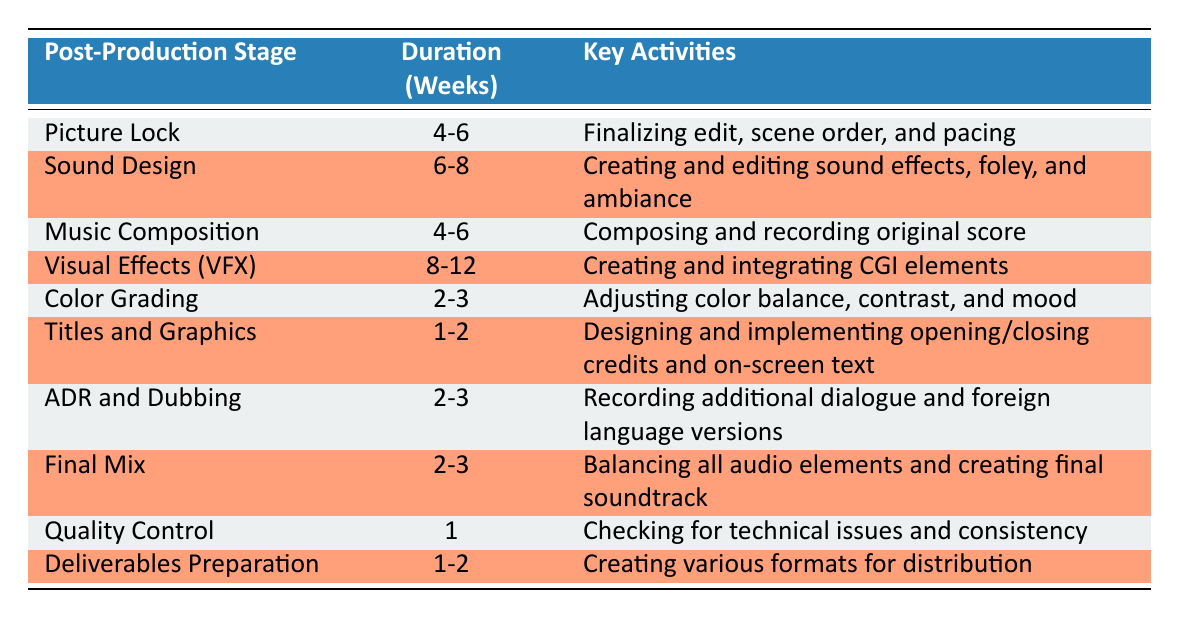What is the duration for the Picture Lock stage? The table lists the duration for the Picture Lock stage as 4-6 weeks.
Answer: 4-6 weeks How many weeks are allocated for Sound Design? The table indicates that Sound Design takes 6-8 weeks.
Answer: 6-8 weeks Is Color Grading shorter in duration than Titles and Graphics? Upon comparing the durations, Color Grading takes 2-3 weeks while Titles and Graphics takes 1-2 weeks. Since 2-3 weeks is greater than 1-2 weeks, this statement is false.
Answer: No What are the key activities during the Visual Effects (VFX) stage? According to the table, the key activities during the Visual Effects (VFX) stage are creating and integrating CGI elements.
Answer: Creating and integrating CGI elements What is the average duration for the ADR and Dubbing and Final Mix stages combined? The duration for ADR and Dubbing is 2-3 weeks and for Final Mix is also 2-3 weeks. To find the average, we will consider the midpoints: for both stages, the midpoint is (2+3)/2 = 2.5 weeks. Therefore, the total is 2.5 + 2.5 = 5 weeks, and the average is 5/2 = 2.5 weeks for the combined duration.
Answer: 2.5 weeks How much longer, on average, does Visual Effects (VFX) take compared to Color Grading? Visual Effects (VFX) takes 8-12 weeks and Color Grading takes 2-3 weeks. To find the average difference, we calculate the midpoints: (8+12)/2 = 10 weeks for VFX and (2+3)/2 = 2.5 weeks for Color Grading. The difference is 10 - 2.5 = 7.5 weeks.
Answer: 7.5 weeks Does the Final Mix stage have a longer duration than Quality Control? The Final Mix stage takes 2-3 weeks while Quality Control takes 1 week. Since 2-3 weeks is longer than 1 week, this statement is true.
Answer: Yes Identify the two post-production stages that have the same duration range. By scanning the table, both Music Composition and Picture Lock have the same duration range of 4-6 weeks.
Answer: Music Composition and Picture Lock How many weeks total are allocated for Color Grading, Titles and Graphics, and Quality Control? The durations are 2-3 weeks for Color Grading, 1-2 weeks for Titles and Graphics, and 1 week for Quality Control. To find the total, we take the maximums of the ranges: 3 (from Color Grading) + 2 (from Titles and Graphics) + 1 = 6 weeks. The minimum total is 2 + 1 + 1 = 4 weeks, leading to a range of 4 to 6 weeks.
Answer: 4-6 weeks 